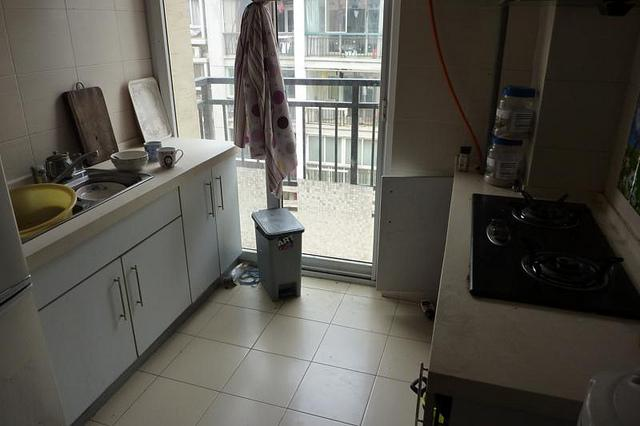In what type of housing complex is this kitchen part of?

Choices:
A) university dorm
B) condominium
C) apartment
D) detached home apartment 